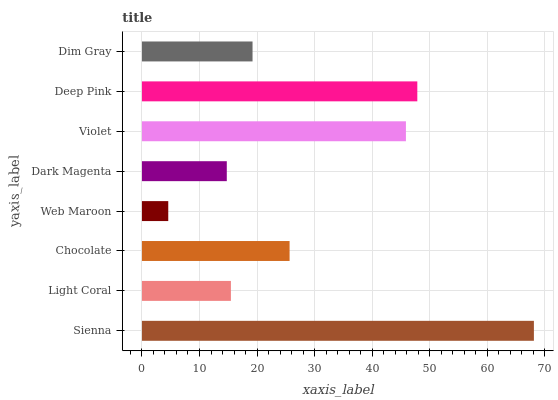Is Web Maroon the minimum?
Answer yes or no. Yes. Is Sienna the maximum?
Answer yes or no. Yes. Is Light Coral the minimum?
Answer yes or no. No. Is Light Coral the maximum?
Answer yes or no. No. Is Sienna greater than Light Coral?
Answer yes or no. Yes. Is Light Coral less than Sienna?
Answer yes or no. Yes. Is Light Coral greater than Sienna?
Answer yes or no. No. Is Sienna less than Light Coral?
Answer yes or no. No. Is Chocolate the high median?
Answer yes or no. Yes. Is Dim Gray the low median?
Answer yes or no. Yes. Is Violet the high median?
Answer yes or no. No. Is Dark Magenta the low median?
Answer yes or no. No. 